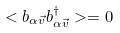Convert formula to latex. <formula><loc_0><loc_0><loc_500><loc_500>< b _ { \alpha \vec { v } } b ^ { \dagger } _ { \alpha \vec { v } } > = 0</formula> 